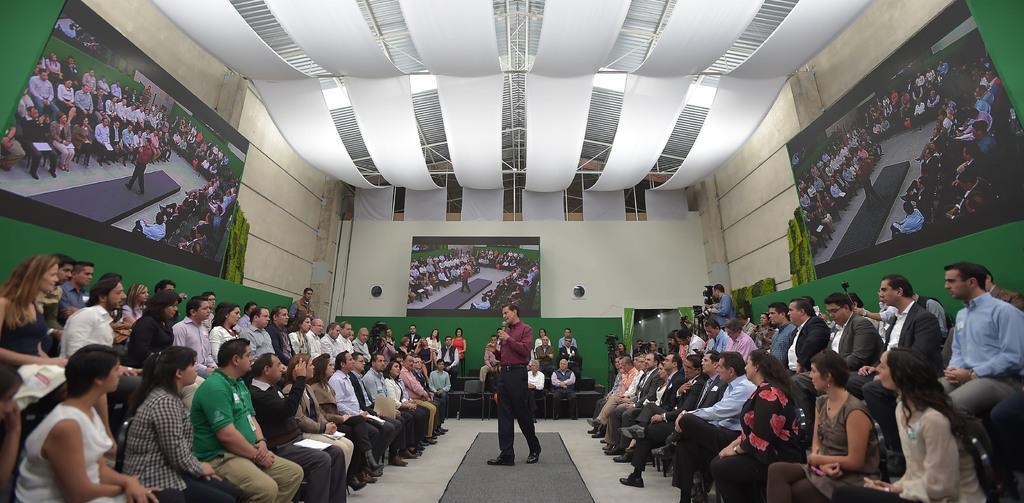In one or two sentences, can you explain what this image depicts? In this image I can see group of people sitting on the chairs and few people are holding something. In front I can see one person is holding a mic. Back I can see few screens attached to the wall. I can see few cameras. 